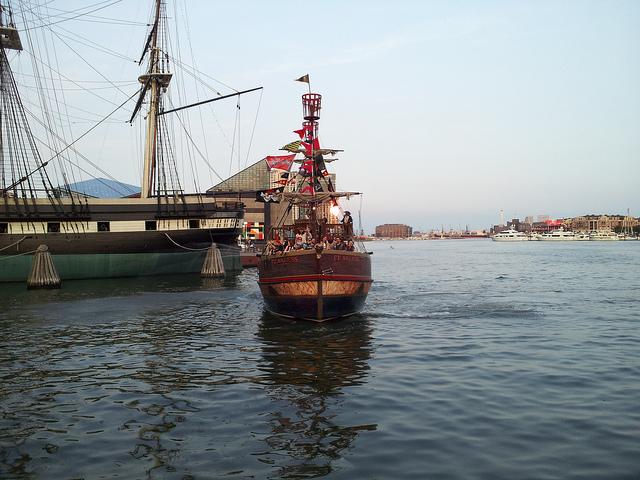What country is this boat from?
Short answer required. England. Is the boat moving?
Give a very brief answer. Yes. How many boats are in the water?
Write a very short answer. 2. 